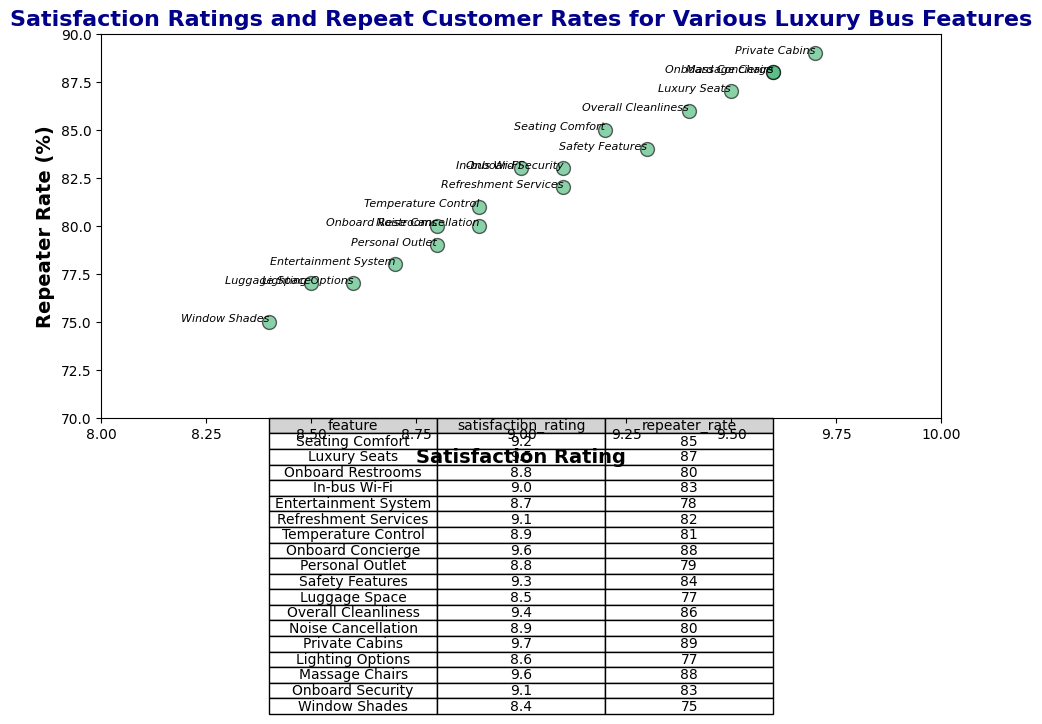How does the satisfaction rating of Private Cabins compare to Massage Chairs? Both Private Cabins and Massage Chairs have a satisfaction rating of 9.6, indicating they are equally highly rated.
Answer: They are the same Which feature has the highest repeater rate? The feature with the highest repeater rate is Private Cabins, with 89%. This can be seen by identifying the highest value in the repeater rate column.
Answer: Private Cabins What is the average satisfaction rating of features with a repeater rate above 85%? Features with repeater rates above 85% are Seating Comfort, Luxury Seats, Onboard Concierge, and Private Cabins with satisfaction ratings of 9.2, 9.5, 9.6, and 9.7 respectively. Summing these ratings gives 38, and dividing by 4 features results in 9.5.
Answer: 9.5 How does the repeater rate of Refreshment Services compare to Onboard Restrooms? Refreshment Services have a repeater rate of 82%, while Onboard Restrooms have a repeater rate of 80%. Thus, Refreshment Services have a slightly higher repeater rate.
Answer: Refreshment Services has a 2% higher repeater rate Which feature has the lowest satisfaction rating, and what is its repeater rate? The feature with the lowest satisfaction rating is Window Shades, rated at 8.4. Its repeater rate is 75%. This can be determined by identifying the lowest value in the satisfaction rating column and looking at the corresponding repeater rate.
Answer: Window Shades, 75% What is the difference in repeater rates between the highest and lowest satisfaction ratings? The highest satisfaction rating is Private Cabins at 9.7 with a repeater rate of 89%. The lowest satisfaction rating is Window Shades at 8.4 with a repeater rate of 75%. The difference in repeater rates is 89% - 75% = 14%.
Answer: 14% Which features have a satisfaction rating of 9.1, and what are their respective repeater rates? The features with a satisfaction rating of 9.1 are Refreshment Services and Onboard Security. Their respective repeater rates are 82% and 83%. This is determined by filtering the satisfaction ratings and corresponding features and repeater rates.
Answer: Refreshment Services: 82%, Onboard Security: 83% Identify the feature with the median satisfaction rating and state its repeater rate. The satisfaction ratings need to be listed in order: (8.4, 8.5, 8.6, 8.7, 8.8, 8.8, 8.9, 8.9, 9.0, 9.1, 9.1, 9.2, 9.3, 9.4, 9.5, 9.6, 9.6, 9.7). The median value is between 8.9 and 9.0 since there are 18 values. Hence, both Temperature Control (8.9, 81%) and In-bus Wi-Fi (9.0, 83%) are considered.
Answer: Temperature Control: 81%, In-bus Wi-Fi: 83% 